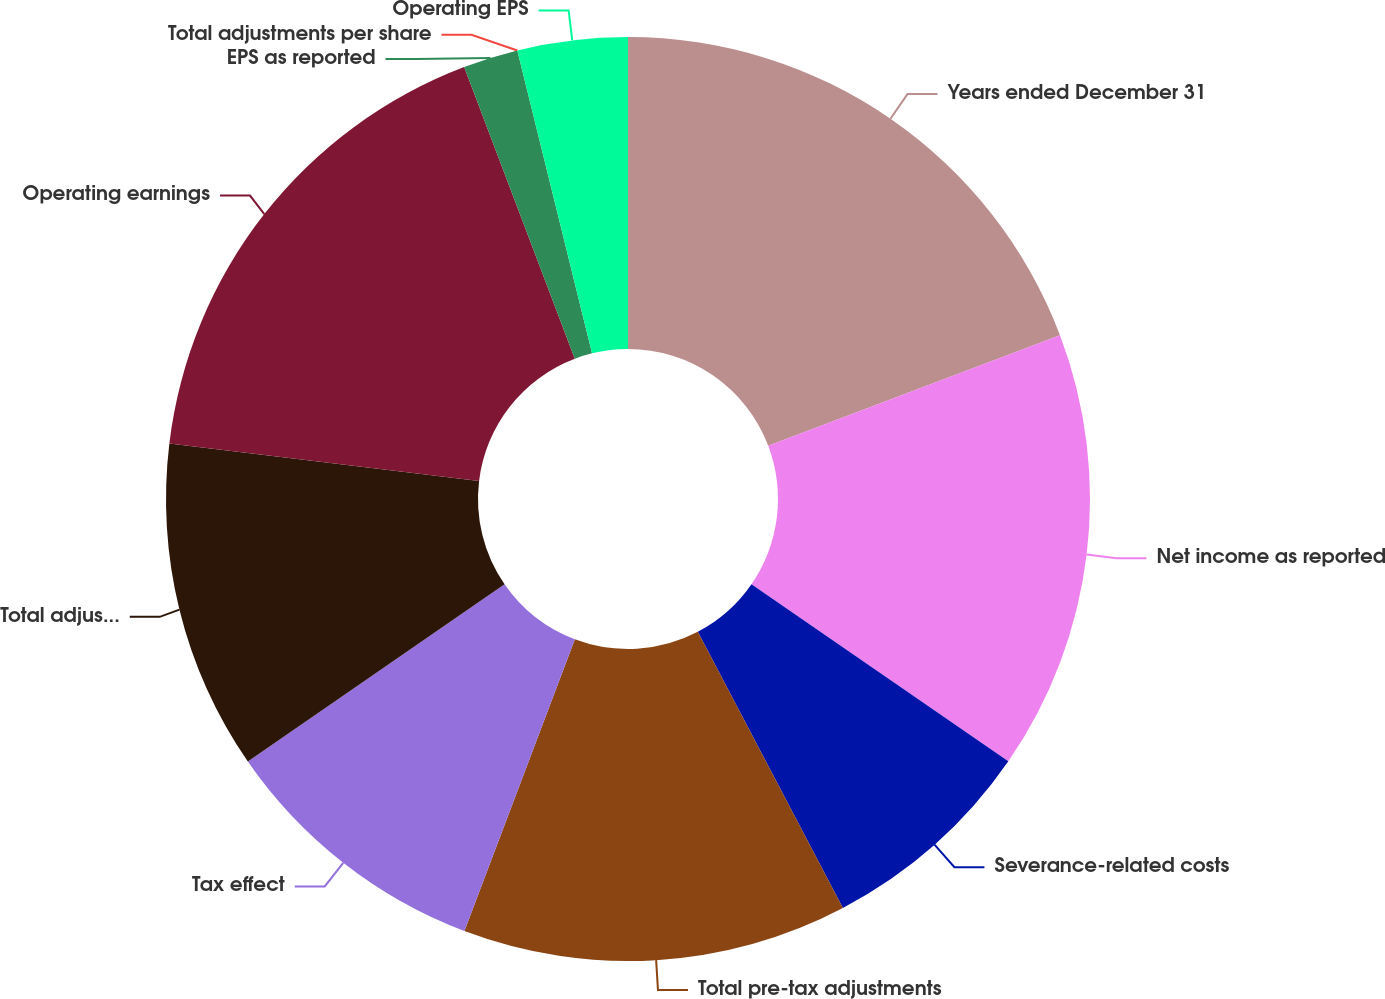Convert chart. <chart><loc_0><loc_0><loc_500><loc_500><pie_chart><fcel>Years ended December 31<fcel>Net income as reported<fcel>Severance-related costs<fcel>Total pre-tax adjustments<fcel>Tax effect<fcel>Total adjustments net of tax<fcel>Operating earnings<fcel>EPS as reported<fcel>Total adjustments per share<fcel>Operating EPS<nl><fcel>19.23%<fcel>15.38%<fcel>7.69%<fcel>13.46%<fcel>9.62%<fcel>11.54%<fcel>17.31%<fcel>1.92%<fcel>0.0%<fcel>3.85%<nl></chart> 